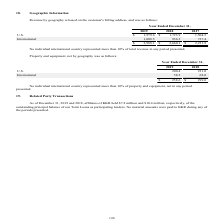According to Godaddy's financial document, How do they determine the geographic location of revenue earned? based on the customer's billing address. The document states: "Revenue by geography is based on the customer's billing address, and was as follows:..." Also, Which 2 geographic segments are listed in the table? The document shows two values: U.S. and International. From the document: ", 2019 2018 2017 U.S. $ 1,979.6 $ 1,723.9 1,504.5 International 1,008.5 936.2 727.4 $ 2,988.1 $ 2,660.1 $ 2,231.9 Year Ended December 31, 2019 2018 20..." Also, What is the U.S. revenue for year ended December 31, 2019 ? According to the financial document, $1,979.6. The relevant text states: "Year Ended December 31, 2019 2018 2017 U.S. $ 1,979.6 $ 1,723.9 1,504.5 International 1,008.5 936.2 727.4 $ 2,988.1 $ 2,660.1 $ 2,231.9..." Also, can you calculate: What is the average U.S. revenue for 2018 and 2019? To answer this question, I need to perform calculations using the financial data. The calculation is: (1,979.6+1,723.9)/2, which equals 1851.75. This is based on the information: "nded December 31, 2019 2018 2017 U.S. $ 1,979.6 $ 1,723.9 1,504.5 International 1,008.5 936.2 727.4 $ 2,988.1 $ 2,660.1 $ 2,231.9 Year Ended December 31, 2019 2018 2017 U.S. $ 1,979.6 $ 1,723.9 1,504...." The key data points involved are: 1,723.9, 1,979.6. Also, can you calculate: What is the average U.S. revenue for 2017 and 2018? To answer this question, I need to perform calculations using the financial data. The calculation is: (1,723.9+1,504.5)/2, which equals 1614.2. This is based on the information: "ember 31, 2019 2018 2017 U.S. $ 1,979.6 $ 1,723.9 1,504.5 International 1,008.5 936.2 727.4 $ 2,988.1 $ 2,660.1 $ 2,231.9 nded December 31, 2019 2018 2017 U.S. $ 1,979.6 $ 1,723.9 1,504.5 Internationa..." The key data points involved are: 1,504.5, 1,723.9. Also, can you calculate: What is the change in the average U.S. revenue between 2017-2018 and 2018-2019? To answer this question, I need to perform calculations using the financial data. The calculation is: [(1,979.6+1,723.9)/2] - [(1,723.9+1,504.5)/2], which equals 237.55. This is based on the information: "ember 31, 2019 2018 2017 U.S. $ 1,979.6 $ 1,723.9 1,504.5 International 1,008.5 936.2 727.4 $ 2,988.1 $ 2,660.1 $ 2,231.9 nded December 31, 2019 2018 2017 U.S. $ 1,979.6 $ 1,723.9 1,504.5 Internationa..." The key data points involved are: 1,504.5, 1,723.9, 1,979.6. 